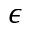Convert formula to latex. <formula><loc_0><loc_0><loc_500><loc_500>\epsilon</formula> 